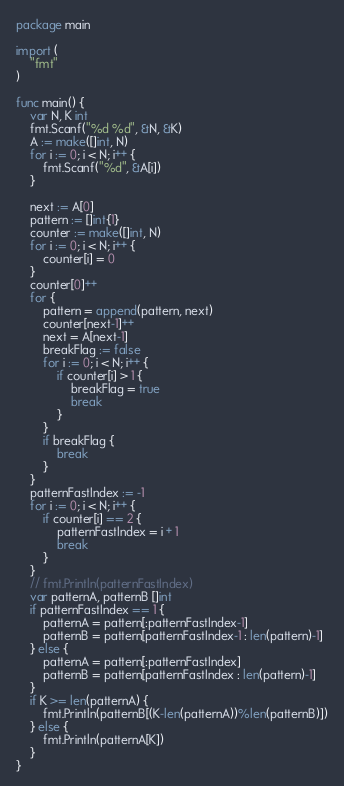<code> <loc_0><loc_0><loc_500><loc_500><_Go_>package main

import (
	"fmt"
)

func main() {
	var N, K int
	fmt.Scanf("%d %d", &N, &K)
	A := make([]int, N)
	for i := 0; i < N; i++ {
		fmt.Scanf("%d", &A[i])
	}

	next := A[0]
	pattern := []int{1}
	counter := make([]int, N)
	for i := 0; i < N; i++ {
		counter[i] = 0
	}
	counter[0]++
	for {
		pattern = append(pattern, next)
		counter[next-1]++
		next = A[next-1]
		breakFlag := false
		for i := 0; i < N; i++ {
			if counter[i] > 1 {
				breakFlag = true
				break
			}
		}
		if breakFlag {
			break
		}
	}
	patternFastIndex := -1
	for i := 0; i < N; i++ {
		if counter[i] == 2 {
			patternFastIndex = i + 1
			break
		}
	}
	// fmt.Println(patternFastIndex)
	var patternA, patternB []int
	if patternFastIndex == 1 {
		patternA = pattern[:patternFastIndex-1]
		patternB = pattern[patternFastIndex-1 : len(pattern)-1]
	} else {
		patternA = pattern[:patternFastIndex]
		patternB = pattern[patternFastIndex : len(pattern)-1]
	}
	if K >= len(patternA) {
		fmt.Println(patternB[(K-len(patternA))%len(patternB)])
	} else {
		fmt.Println(patternA[K])
	}
}
</code> 